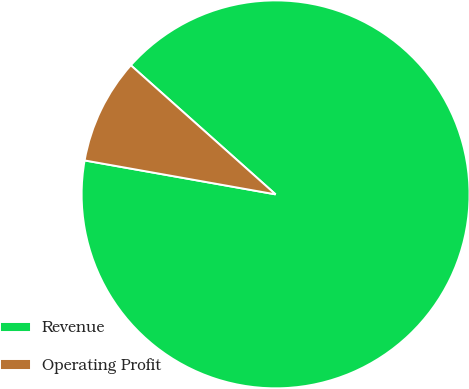Convert chart to OTSL. <chart><loc_0><loc_0><loc_500><loc_500><pie_chart><fcel>Revenue<fcel>Operating Profit<nl><fcel>91.21%<fcel>8.79%<nl></chart> 